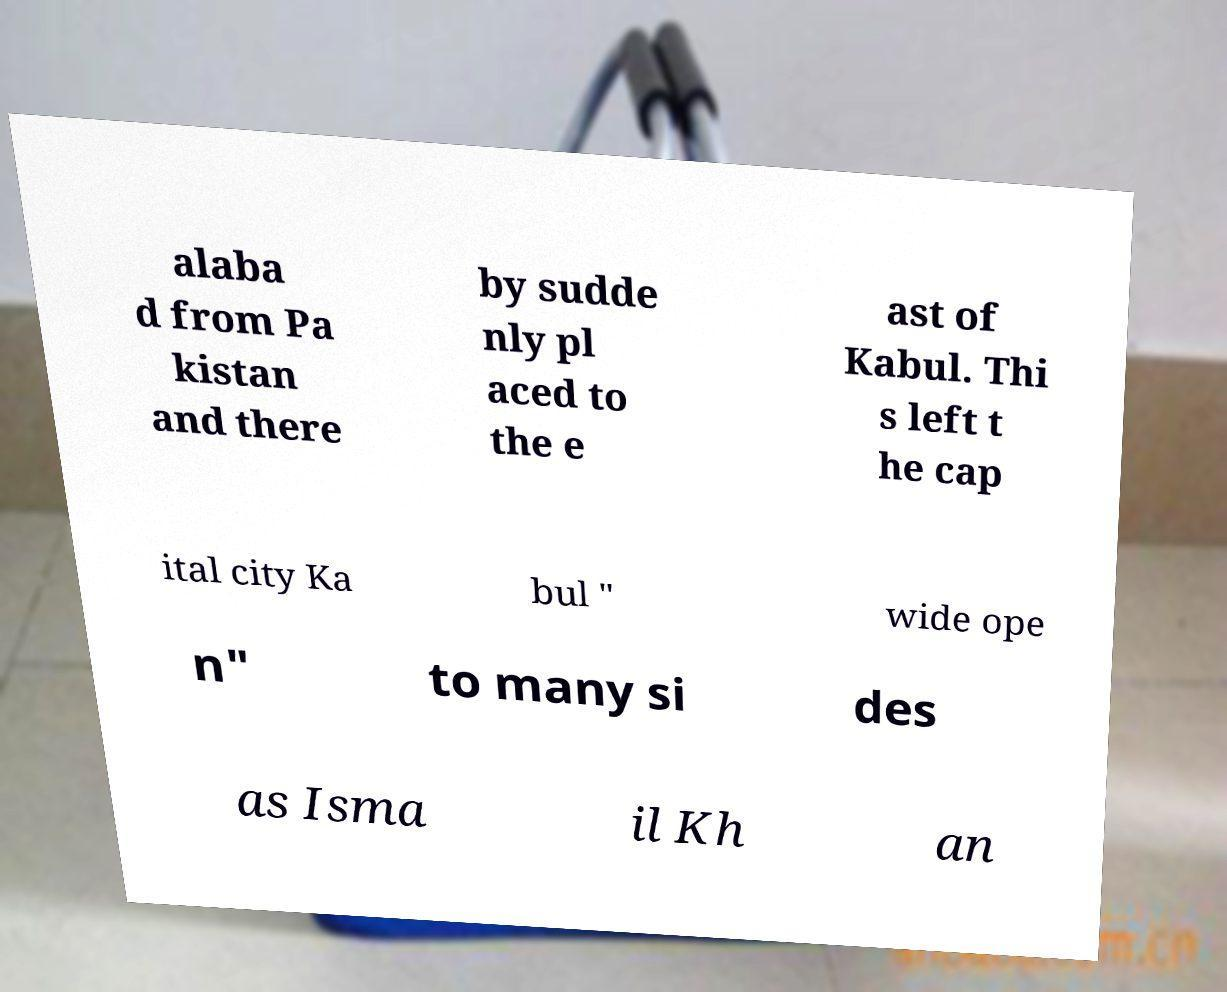Please read and relay the text visible in this image. What does it say? alaba d from Pa kistan and there by sudde nly pl aced to the e ast of Kabul. Thi s left t he cap ital city Ka bul " wide ope n" to many si des as Isma il Kh an 